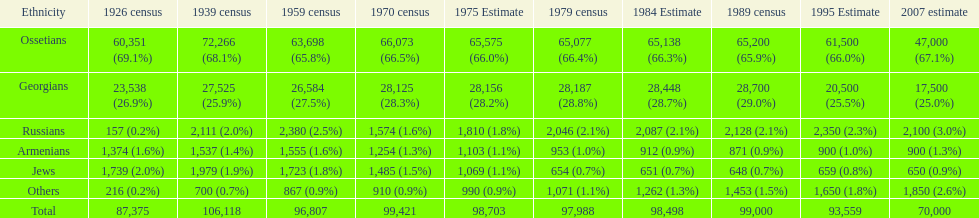What ethnicity is at the top? Ossetians. 